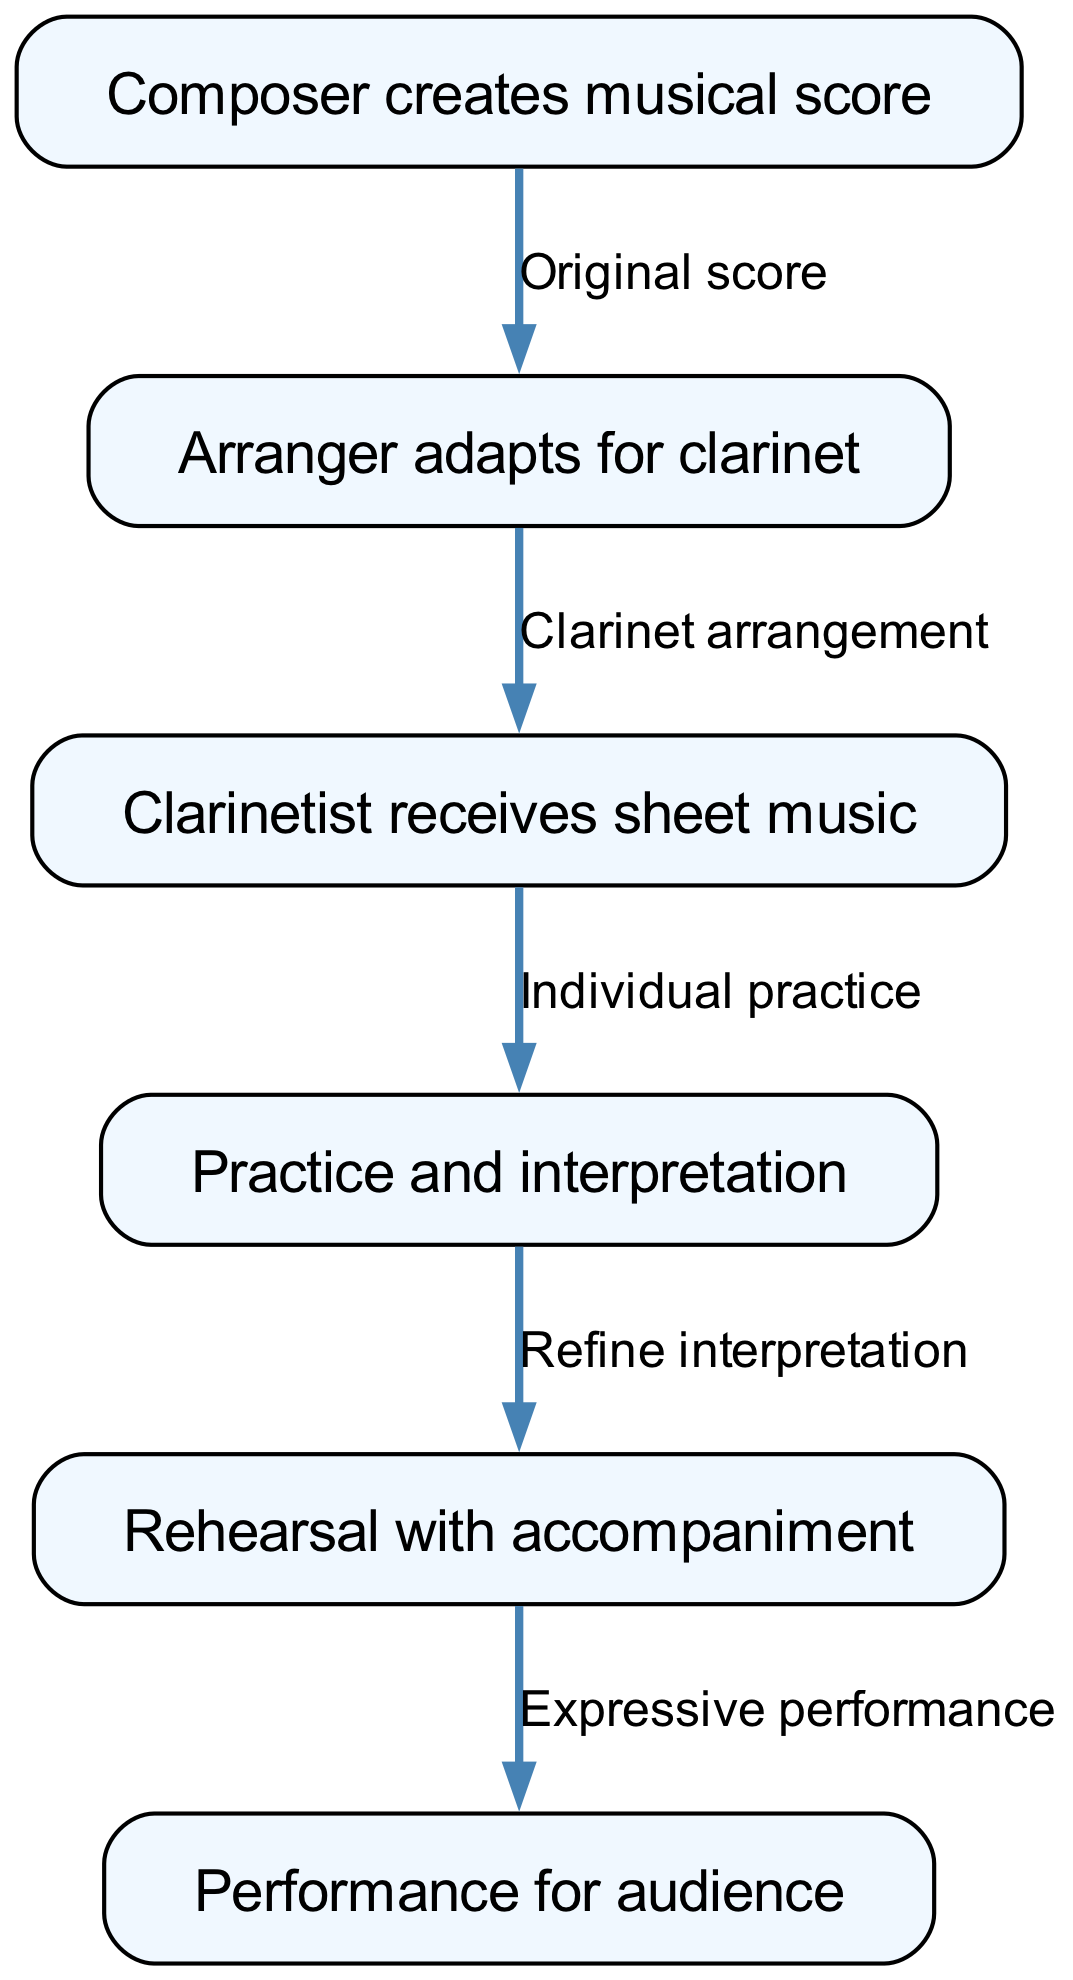What is the first step in the journey of a musical piece? The first node in the flow chart indicates that the journey begins with the "Composer creates musical score."
Answer: Composer creates musical score How many nodes are there in the diagram? The diagram lists a total of six unique actions or steps, each represented as a node.
Answer: 6 What type of arrangement is made after the composer creates the score? Looking at the edges, the flow indicates that after the original score, the next action is "Arranger adapts for clarinet."
Answer: Clarinet arrangement Which node represents the stage where the clarinetist practices? The third node references "Individual practice," which is the stage when the clarinetist practices the music.
Answer: Individual practice What is the final step in the diagram? The last node in the flow chart is marked as "Performance for audience," indicating this is the final action in the journey.
Answer: Performance for audience What relationship does "Refine interpretation" have with "Practice and interpretation"? The flow shows that "Refine interpretation" is the step following "Practice and interpretation," illustrating a progression in the journey.
Answer: Next step What must happen before the "Performance for audience" can take place? The diagram indicates that after "Rehearsal with accompaniment," the performance is the next step, so rehearsal must happen first.
Answer: Rehearsal with accompaniment How many edges are present in the diagram? Each edge connects two nodes. Upon counting, we find that there are five connections, representing transitions between the steps.
Answer: 5 What does the arranger do in this journey? The diagram specifies the arrangers' role as adapting the composed score specifically for the clarinet.
Answer: Adapts for clarinet 